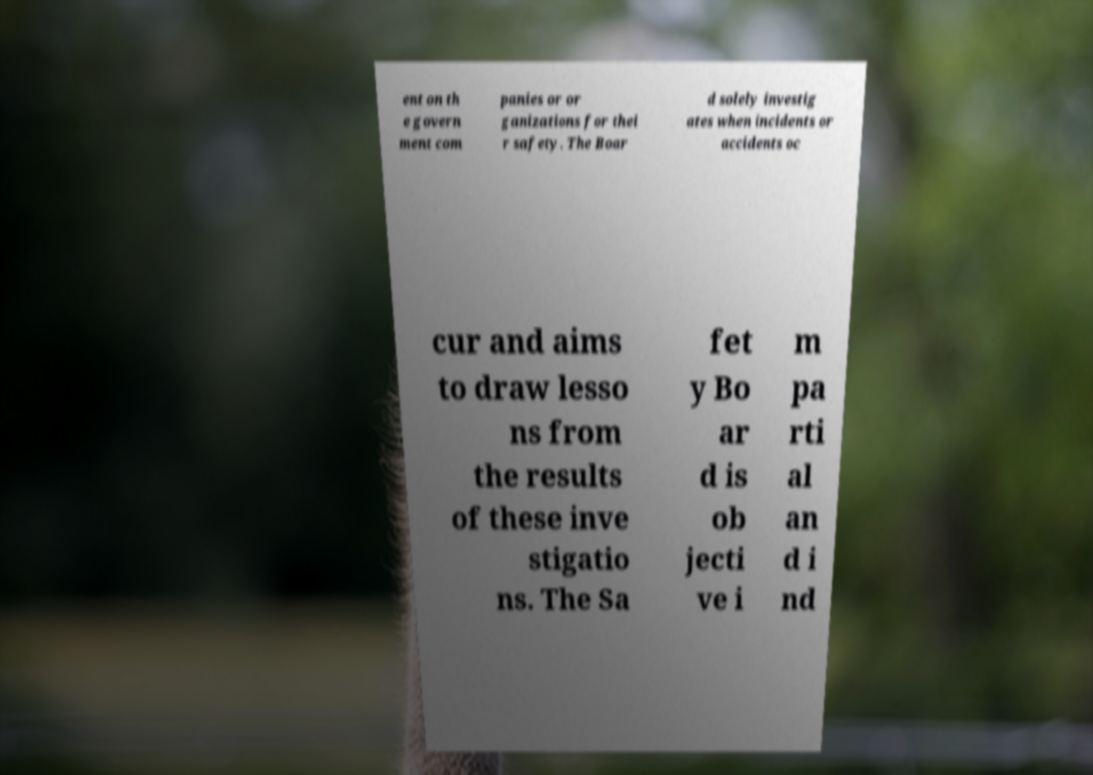Please identify and transcribe the text found in this image. ent on th e govern ment com panies or or ganizations for thei r safety. The Boar d solely investig ates when incidents or accidents oc cur and aims to draw lesso ns from the results of these inve stigatio ns. The Sa fet y Bo ar d is ob jecti ve i m pa rti al an d i nd 